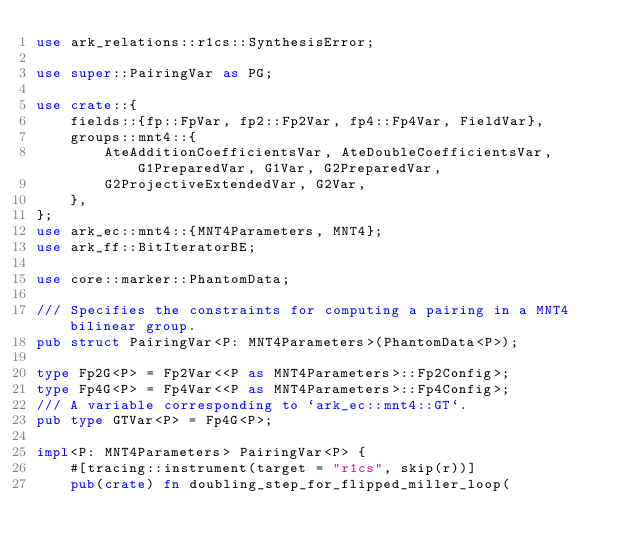Convert code to text. <code><loc_0><loc_0><loc_500><loc_500><_Rust_>use ark_relations::r1cs::SynthesisError;

use super::PairingVar as PG;

use crate::{
    fields::{fp::FpVar, fp2::Fp2Var, fp4::Fp4Var, FieldVar},
    groups::mnt4::{
        AteAdditionCoefficientsVar, AteDoubleCoefficientsVar, G1PreparedVar, G1Var, G2PreparedVar,
        G2ProjectiveExtendedVar, G2Var,
    },
};
use ark_ec::mnt4::{MNT4Parameters, MNT4};
use ark_ff::BitIteratorBE;

use core::marker::PhantomData;

/// Specifies the constraints for computing a pairing in a MNT4 bilinear group.
pub struct PairingVar<P: MNT4Parameters>(PhantomData<P>);

type Fp2G<P> = Fp2Var<<P as MNT4Parameters>::Fp2Config>;
type Fp4G<P> = Fp4Var<<P as MNT4Parameters>::Fp4Config>;
/// A variable corresponding to `ark_ec::mnt4::GT`.
pub type GTVar<P> = Fp4G<P>;

impl<P: MNT4Parameters> PairingVar<P> {
    #[tracing::instrument(target = "r1cs", skip(r))]
    pub(crate) fn doubling_step_for_flipped_miller_loop(</code> 